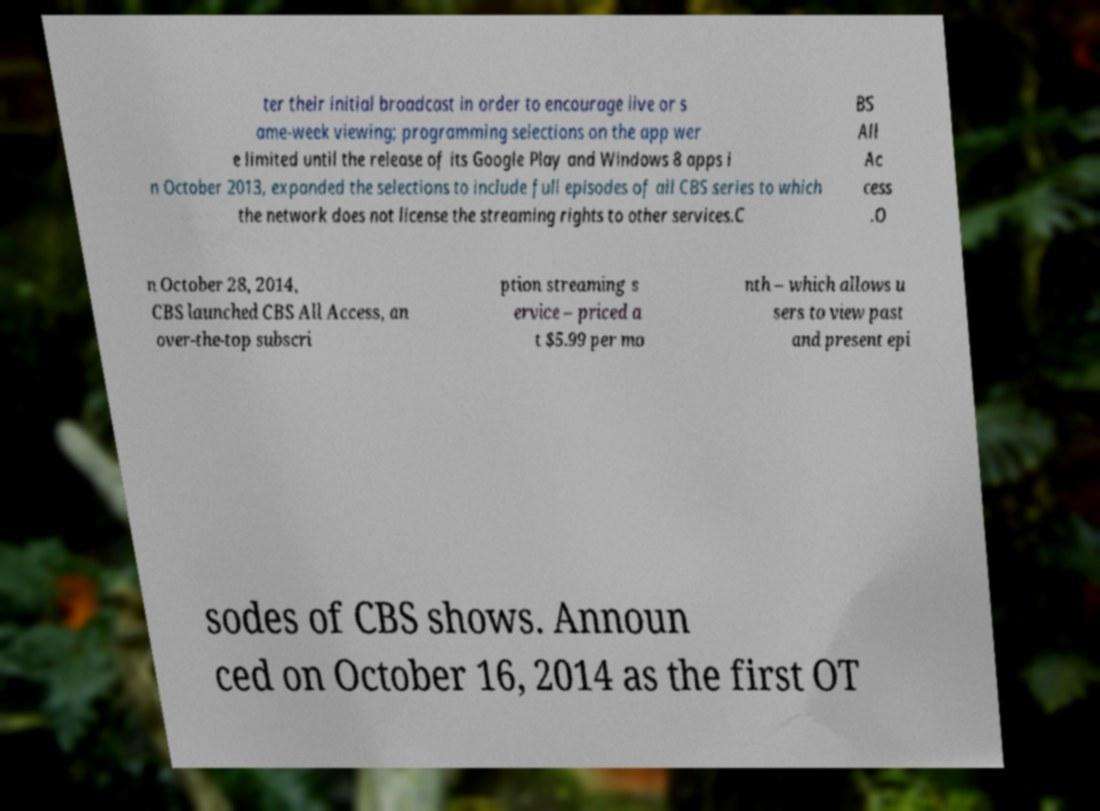Could you assist in decoding the text presented in this image and type it out clearly? ter their initial broadcast in order to encourage live or s ame-week viewing; programming selections on the app wer e limited until the release of its Google Play and Windows 8 apps i n October 2013, expanded the selections to include full episodes of all CBS series to which the network does not license the streaming rights to other services.C BS All Ac cess .O n October 28, 2014, CBS launched CBS All Access, an over-the-top subscri ption streaming s ervice – priced a t $5.99 per mo nth – which allows u sers to view past and present epi sodes of CBS shows. Announ ced on October 16, 2014 as the first OT 